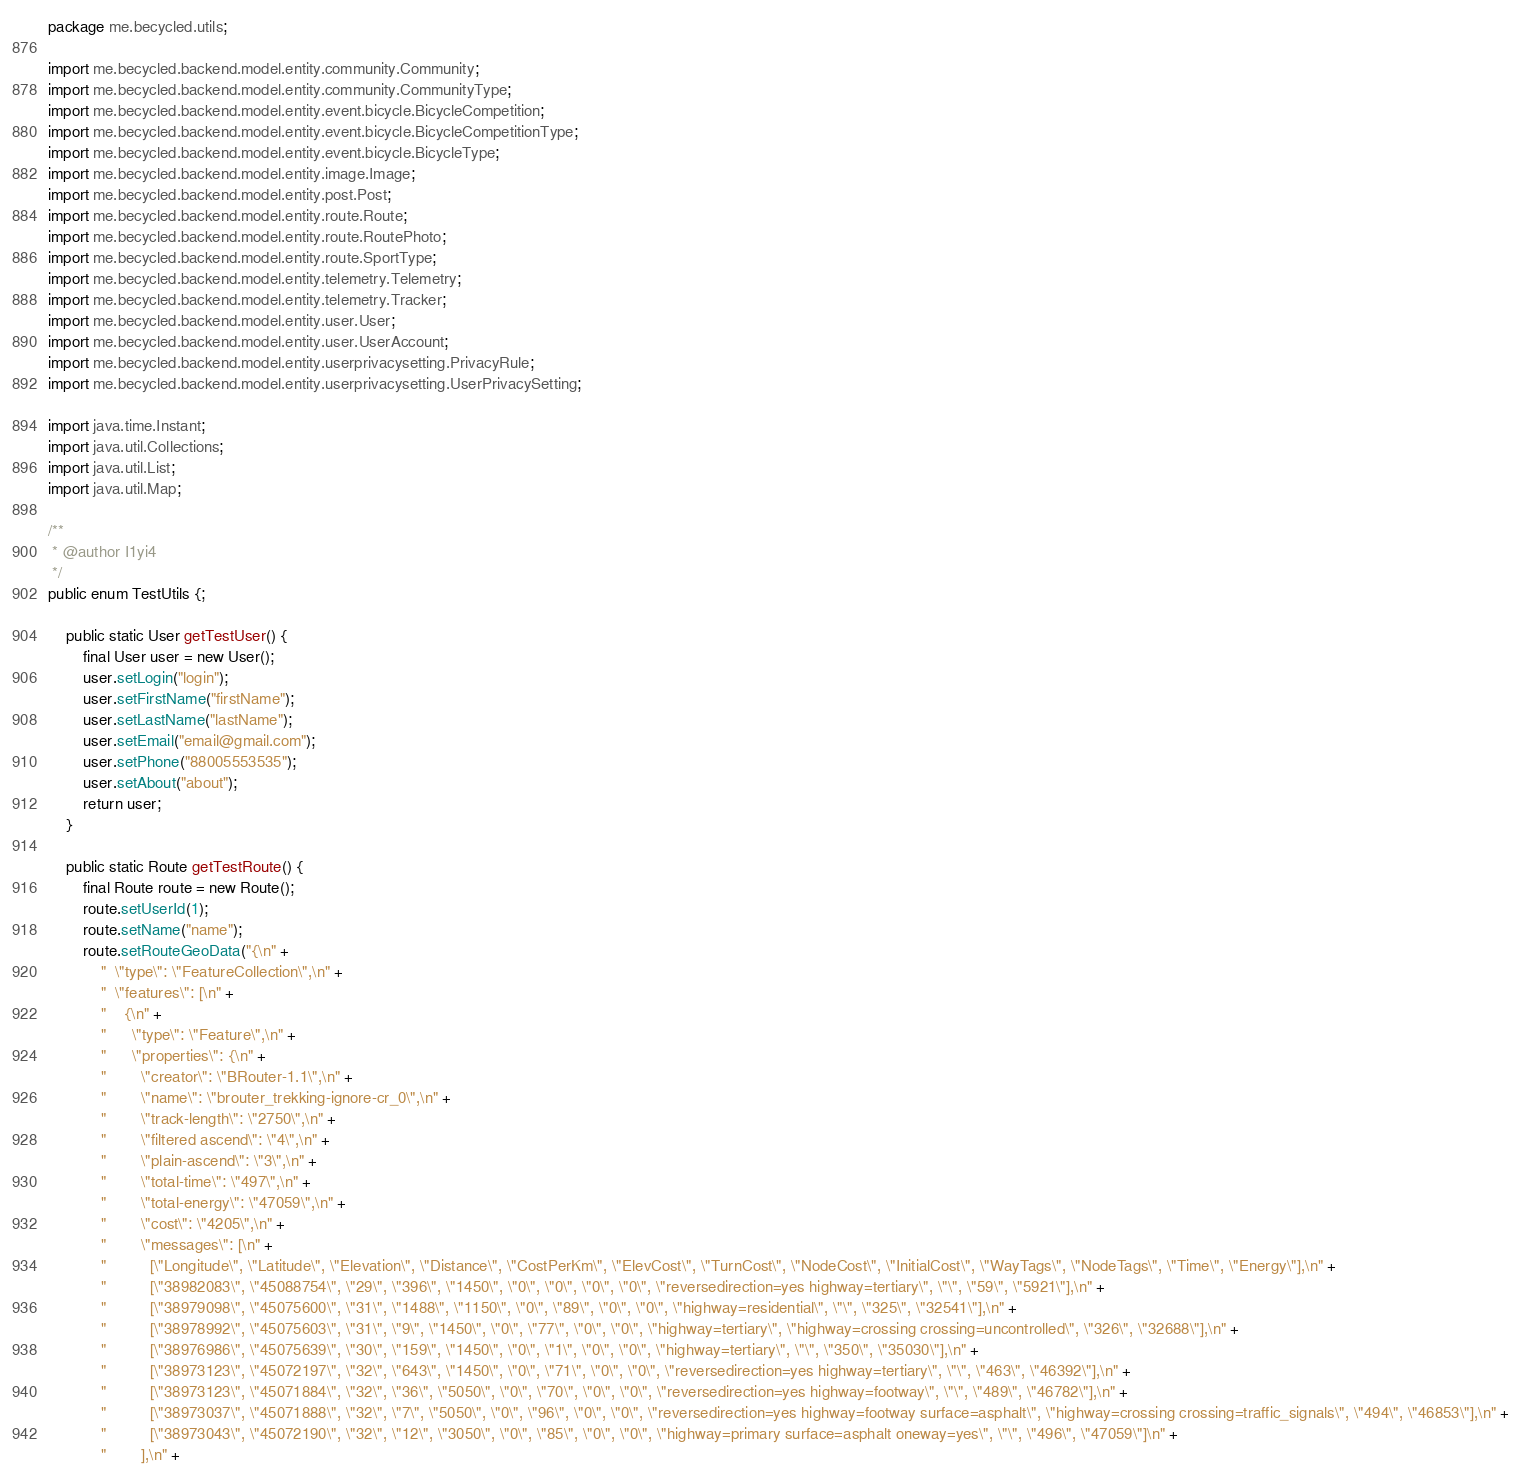Convert code to text. <code><loc_0><loc_0><loc_500><loc_500><_Java_>package me.becycled.utils;

import me.becycled.backend.model.entity.community.Community;
import me.becycled.backend.model.entity.community.CommunityType;
import me.becycled.backend.model.entity.event.bicycle.BicycleCompetition;
import me.becycled.backend.model.entity.event.bicycle.BicycleCompetitionType;
import me.becycled.backend.model.entity.event.bicycle.BicycleType;
import me.becycled.backend.model.entity.image.Image;
import me.becycled.backend.model.entity.post.Post;
import me.becycled.backend.model.entity.route.Route;
import me.becycled.backend.model.entity.route.RoutePhoto;
import me.becycled.backend.model.entity.route.SportType;
import me.becycled.backend.model.entity.telemetry.Telemetry;
import me.becycled.backend.model.entity.telemetry.Tracker;
import me.becycled.backend.model.entity.user.User;
import me.becycled.backend.model.entity.user.UserAccount;
import me.becycled.backend.model.entity.userprivacysetting.PrivacyRule;
import me.becycled.backend.model.entity.userprivacysetting.UserPrivacySetting;

import java.time.Instant;
import java.util.Collections;
import java.util.List;
import java.util.Map;

/**
 * @author I1yi4
 */
public enum TestUtils {;

    public static User getTestUser() {
        final User user = new User();
        user.setLogin("login");
        user.setFirstName("firstName");
        user.setLastName("lastName");
        user.setEmail("email@gmail.com");
        user.setPhone("88005553535");
        user.setAbout("about");
        return user;
    }

    public static Route getTestRoute() {
        final Route route = new Route();
        route.setUserId(1);
        route.setName("name");
        route.setRouteGeoData("{\n" +
            "  \"type\": \"FeatureCollection\",\n" +
            "  \"features\": [\n" +
            "    {\n" +
            "      \"type\": \"Feature\",\n" +
            "      \"properties\": {\n" +
            "        \"creator\": \"BRouter-1.1\",\n" +
            "        \"name\": \"brouter_trekking-ignore-cr_0\",\n" +
            "        \"track-length\": \"2750\",\n" +
            "        \"filtered ascend\": \"4\",\n" +
            "        \"plain-ascend\": \"3\",\n" +
            "        \"total-time\": \"497\",\n" +
            "        \"total-energy\": \"47059\",\n" +
            "        \"cost\": \"4205\",\n" +
            "        \"messages\": [\n" +
            "          [\"Longitude\", \"Latitude\", \"Elevation\", \"Distance\", \"CostPerKm\", \"ElevCost\", \"TurnCost\", \"NodeCost\", \"InitialCost\", \"WayTags\", \"NodeTags\", \"Time\", \"Energy\"],\n" +
            "          [\"38982083\", \"45088754\", \"29\", \"396\", \"1450\", \"0\", \"0\", \"0\", \"0\", \"reversedirection=yes highway=tertiary\", \"\", \"59\", \"5921\"],\n" +
            "          [\"38979098\", \"45075600\", \"31\", \"1488\", \"1150\", \"0\", \"89\", \"0\", \"0\", \"highway=residential\", \"\", \"325\", \"32541\"],\n" +
            "          [\"38978992\", \"45075603\", \"31\", \"9\", \"1450\", \"0\", \"77\", \"0\", \"0\", \"highway=tertiary\", \"highway=crossing crossing=uncontrolled\", \"326\", \"32688\"],\n" +
            "          [\"38976986\", \"45075639\", \"30\", \"159\", \"1450\", \"0\", \"1\", \"0\", \"0\", \"highway=tertiary\", \"\", \"350\", \"35030\"],\n" +
            "          [\"38973123\", \"45072197\", \"32\", \"643\", \"1450\", \"0\", \"71\", \"0\", \"0\", \"reversedirection=yes highway=tertiary\", \"\", \"463\", \"46392\"],\n" +
            "          [\"38973123\", \"45071884\", \"32\", \"36\", \"5050\", \"0\", \"70\", \"0\", \"0\", \"reversedirection=yes highway=footway\", \"\", \"489\", \"46782\"],\n" +
            "          [\"38973037\", \"45071888\", \"32\", \"7\", \"5050\", \"0\", \"96\", \"0\", \"0\", \"reversedirection=yes highway=footway surface=asphalt\", \"highway=crossing crossing=traffic_signals\", \"494\", \"46853\"],\n" +
            "          [\"38973043\", \"45072190\", \"32\", \"12\", \"3050\", \"0\", \"85\", \"0\", \"0\", \"highway=primary surface=asphalt oneway=yes\", \"\", \"496\", \"47059\"]\n" +
            "        ],\n" +</code> 